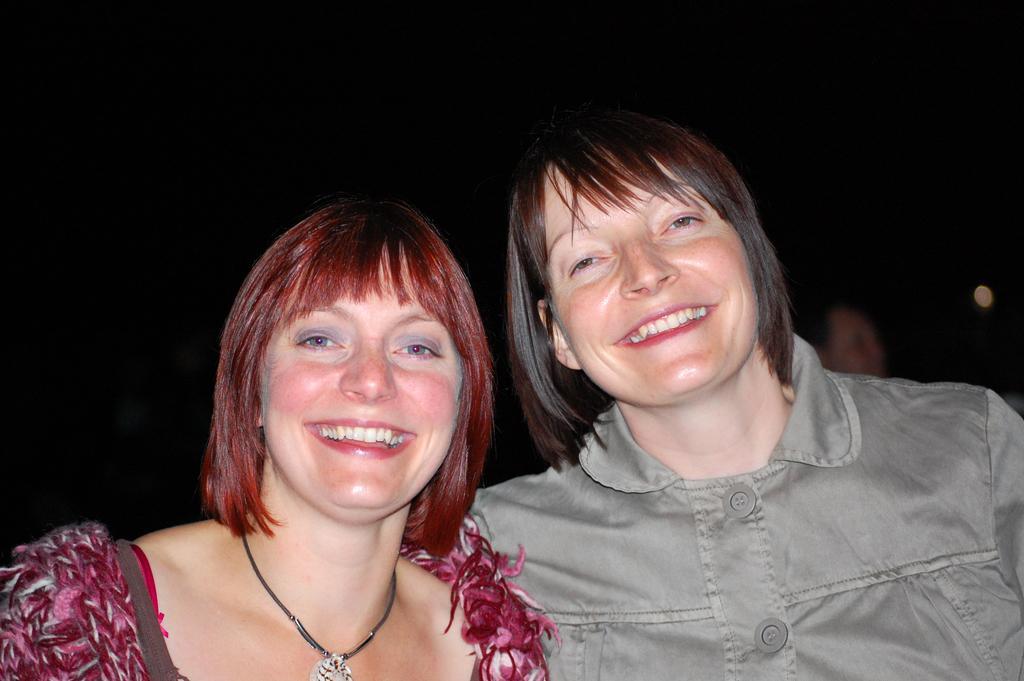Please provide a concise description of this image. In this picture I can see the two persons in the middle, they are smiling, on the right side I can see other person with blur. 